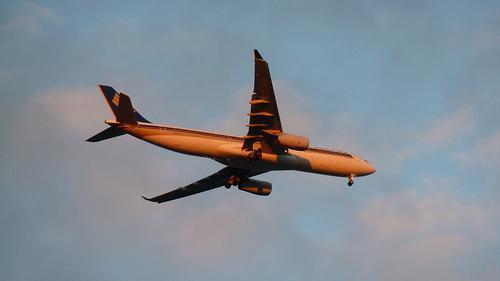How many engines does the plane have?
Give a very brief answer. 2. How many wings are on the plane?
Give a very brief answer. 2. How many motors on the plane?
Give a very brief answer. 2. 